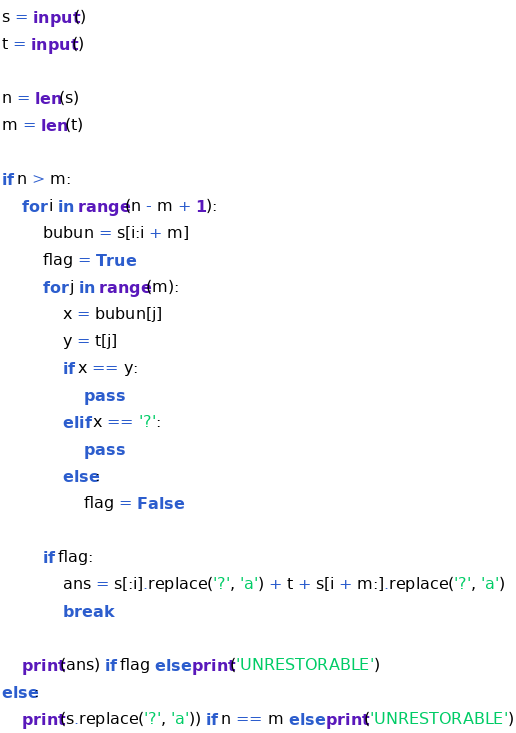Convert code to text. <code><loc_0><loc_0><loc_500><loc_500><_Python_>s = input()
t = input()

n = len(s)
m = len(t)

if n > m:
    for i in range(n - m + 1):
        bubun = s[i:i + m]
        flag = True
        for j in range(m):
            x = bubun[j]
            y = t[j]
            if x == y:
                pass
            elif x == '?':
                pass
            else:
                flag = False

        if flag:
            ans = s[:i].replace('?', 'a') + t + s[i + m:].replace('?', 'a')
            break

    print(ans) if flag else print('UNRESTORABLE')
else:
    print(s.replace('?', 'a')) if n == m else print('UNRESTORABLE')
</code> 